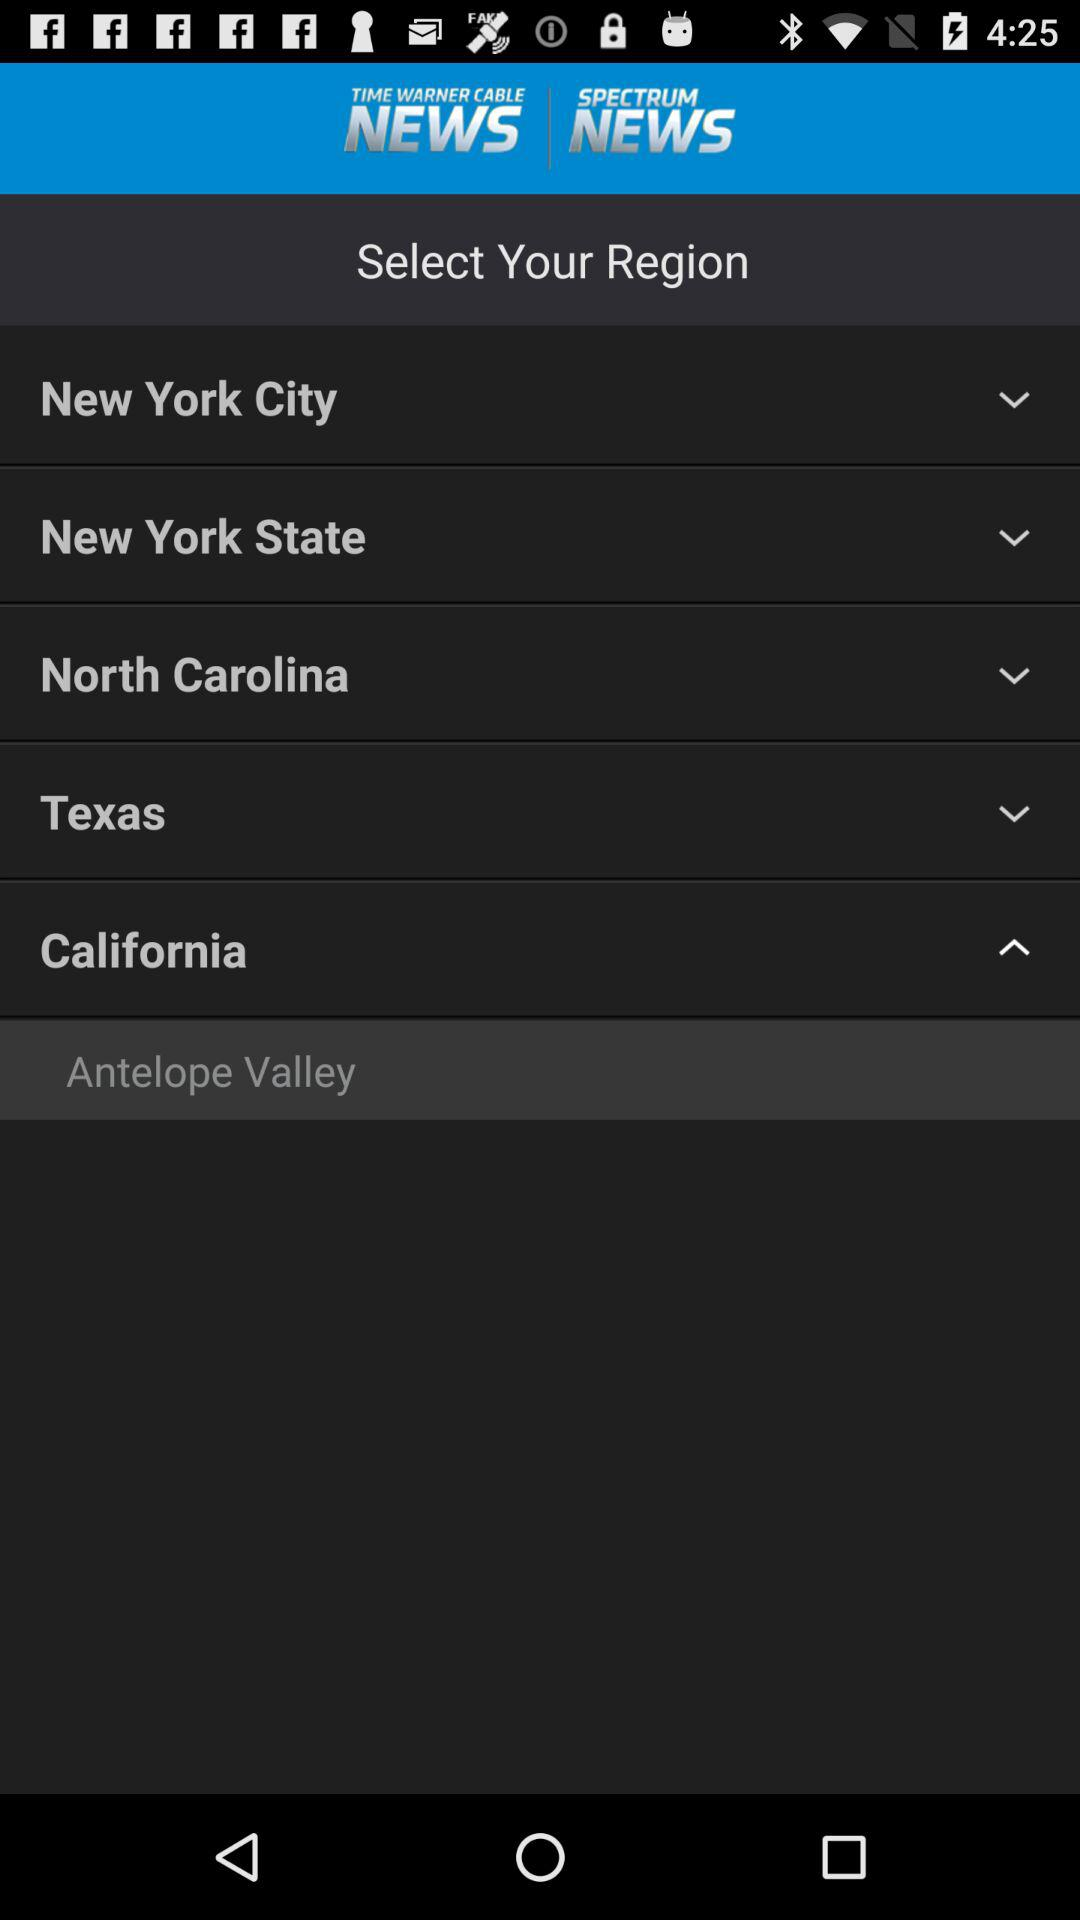What is the selected region? The selected region is "Antelope Valley". 